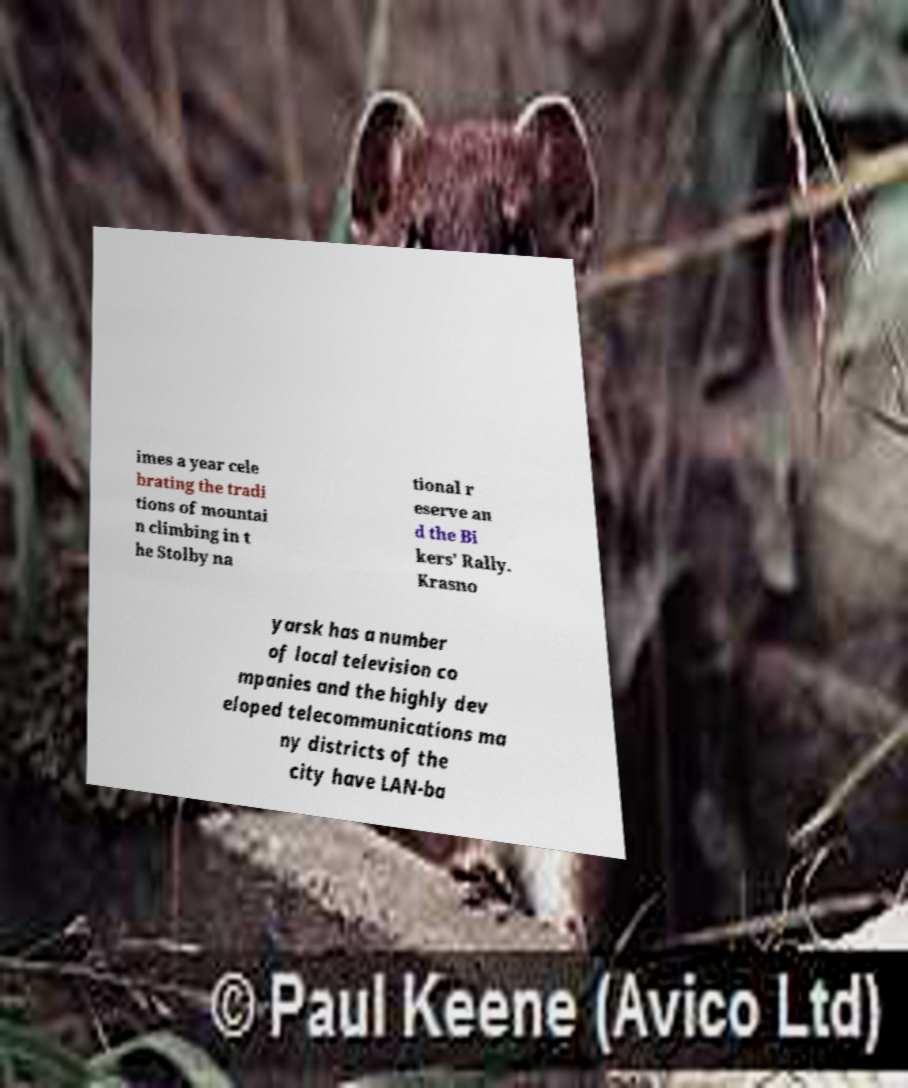I need the written content from this picture converted into text. Can you do that? imes a year cele brating the tradi tions of mountai n climbing in t he Stolby na tional r eserve an d the Bi kers' Rally. Krasno yarsk has a number of local television co mpanies and the highly dev eloped telecommunications ma ny districts of the city have LAN-ba 